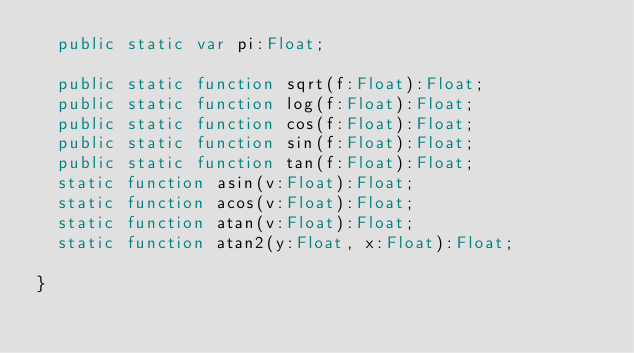Convert code to text. <code><loc_0><loc_0><loc_500><loc_500><_Haxe_>	public static var pi:Float;

	public static function sqrt(f:Float):Float;
	public static function log(f:Float):Float;
	public static function cos(f:Float):Float;
	public static function sin(f:Float):Float;
	public static function tan(f:Float):Float;
	static function asin(v:Float):Float;
	static function acos(v:Float):Float;
	static function atan(v:Float):Float;
	static function atan2(y:Float, x:Float):Float;

}</code> 